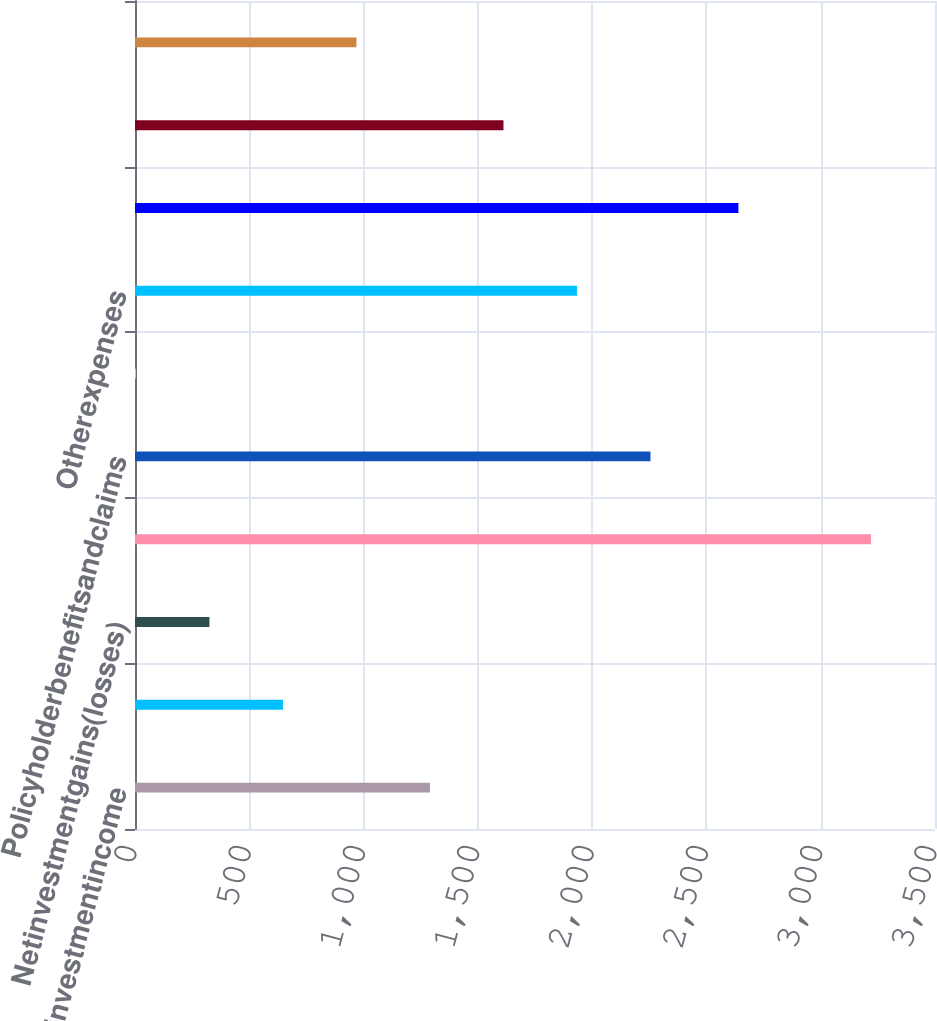Convert chart to OTSL. <chart><loc_0><loc_0><loc_500><loc_500><bar_chart><fcel>Netinvestmentincome<fcel>Otherrevenues<fcel>Netinvestmentgains(losses)<fcel>Totalrevenues<fcel>Policyholderbenefitsandclaims<fcel>Policyholderdividends<fcel>Otherexpenses<fcel>Totalexpenses<fcel>Unnamed: 8<fcel>Provisionforincometax<nl><fcel>1290.4<fcel>647.2<fcel>325.6<fcel>3220<fcel>2255.2<fcel>4<fcel>1933.6<fcel>2640<fcel>1612<fcel>968.8<nl></chart> 